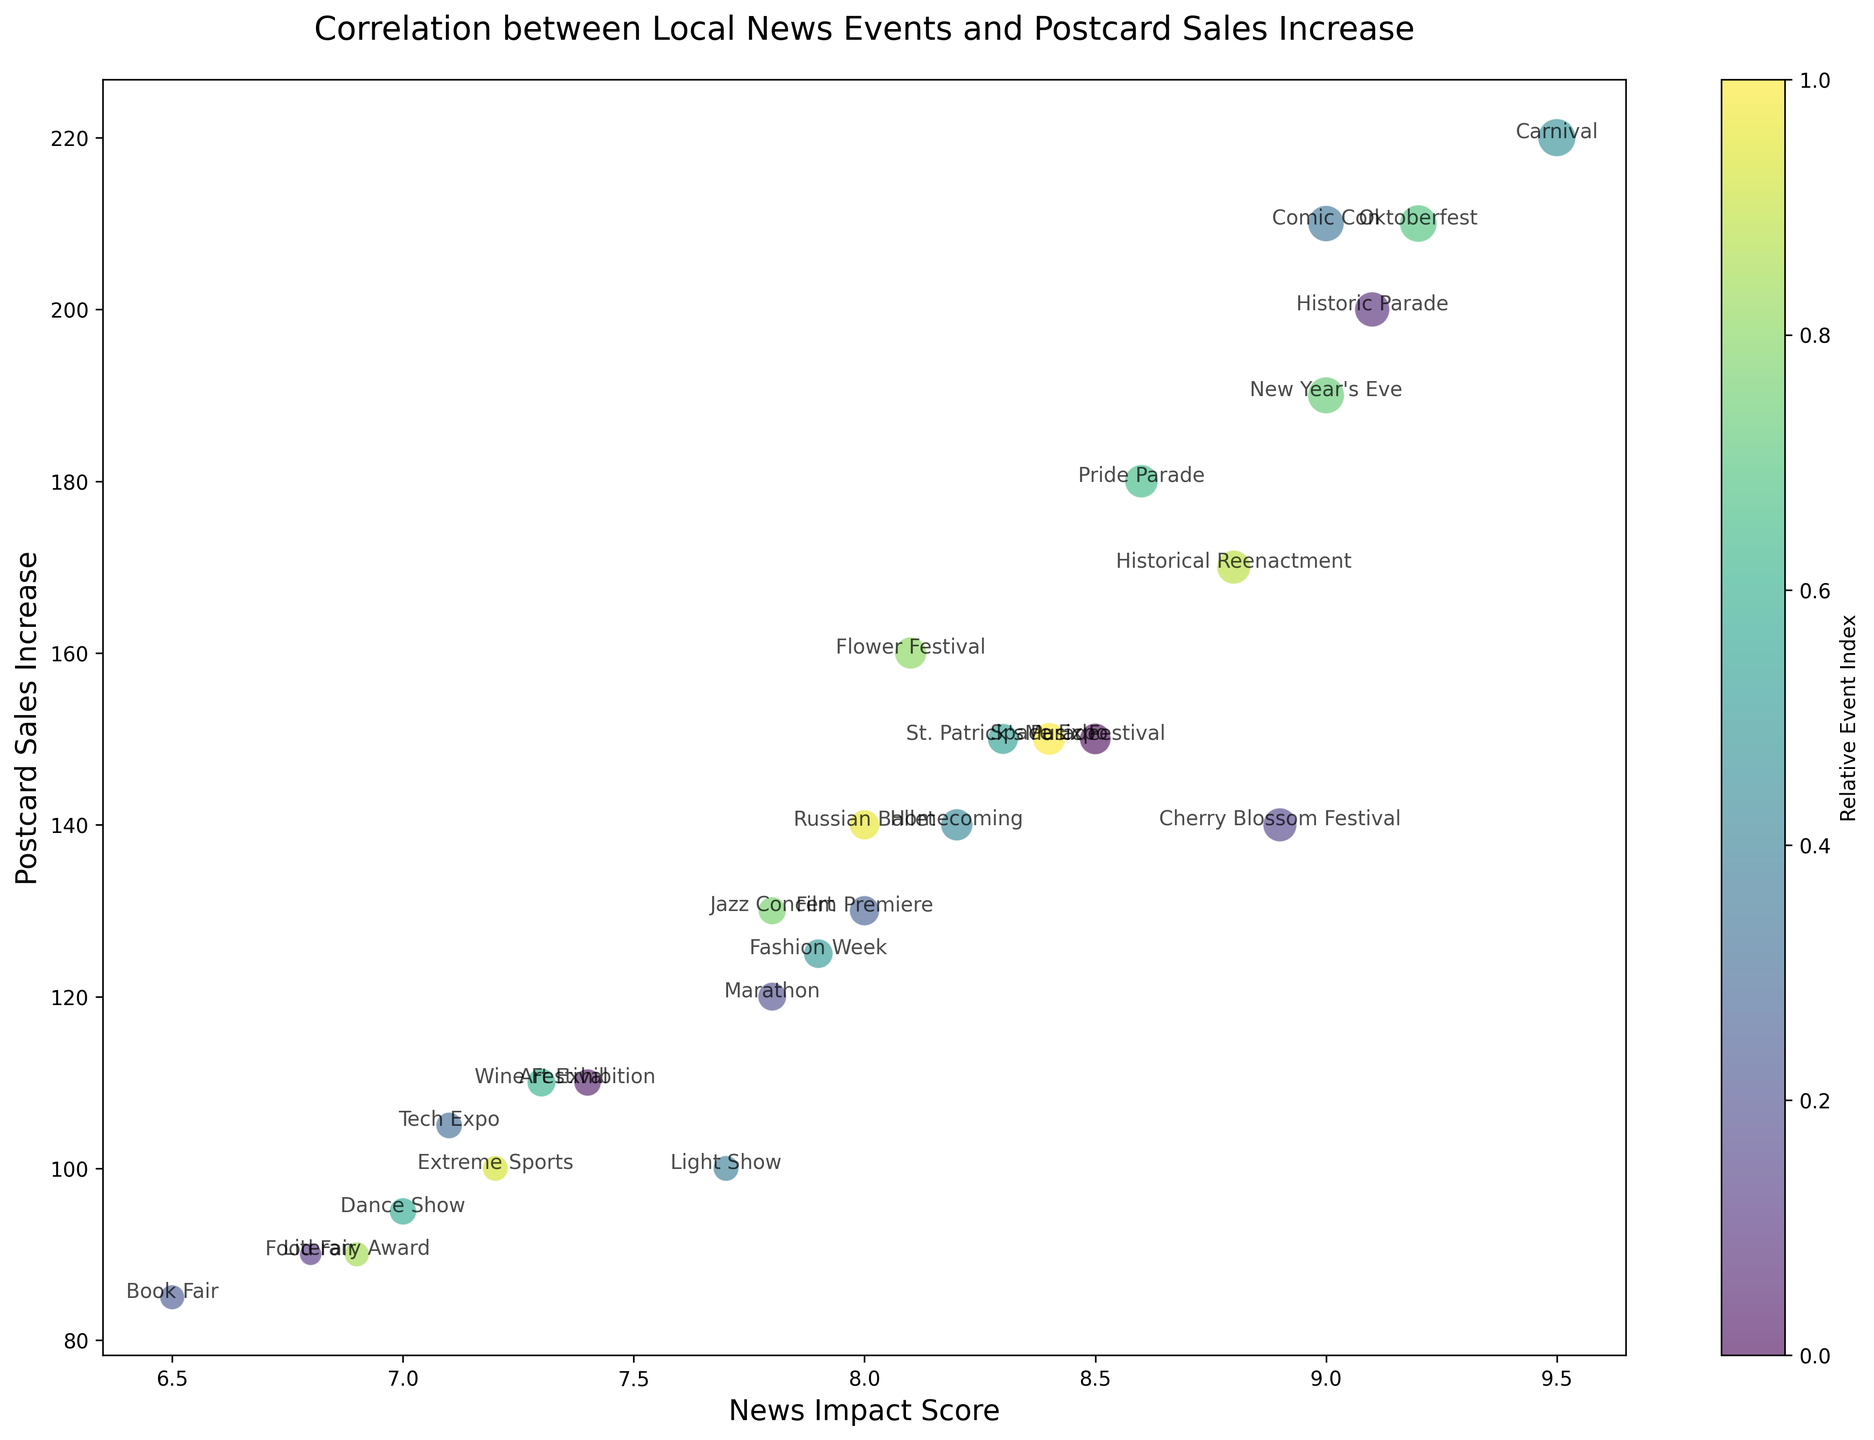What event corresponds to the highest increase in postcard sales? The event with the highest increase in postcard sales can be identified by looking for the highest point on the y-axis. The event labeled "Carnival" in Rio de Janeiro shows the highest increase at 220.
Answer: Carnival Which event had the highest News Impact Score? To find the event with the highest News Impact Score, one should look for the point furthest to the right on the x-axis. The event labeled "Carnival" corresponds to the highest News Impact Score of 9.5.
Answer: Carnival What is the general trend between News Impact Score and Postcard Sales Increase? Observing the overall distribution and direction of the bubbles, there appears to be a positive correlation between the News Impact Score (x-axis) and Postcard Sales Increase (y-axis). Higher News Impact Scores tend to be associated with higher increases in postcard sales.
Answer: Positive correlation Which event with a News Impact Score of at least 8.0 but less than 9.0 had the highest postcard sales increase? Within the News Impact Score range of 8.0 to 8.9, looking at the y-axis for the highest value, the event "Pride Parade" in San Francisco has a postcard sales increase of 180.
Answer: Pride Parade How does the popularity index affect the marker size in the plot? Bubbles with a higher Postcard Popularity Index are shown with larger marker sizes. For instance, the Carnival event, which has a high index, is represented by a larger bubble.
Answer: Larger index, larger marker Which event has a lower Postcard Sales Increase, the Jazz Concert or the Dance Show? By locating the "Jazz Concert" and "Dance Show" on the chart, it is visible that the "Jazz Concert" has a Postcard Sales Increase of 130 while the "Dance Show" has 95.
Answer: Dance Show Which locality has the most frequent event occurrences based on the plot? By examining the event labels, it is noticed that "SF" (San Francisco) appears multiple times with events like "Art Exhibition," "Pride Parade," and "Tech Expo."
Answer: SF Which event had a Postcard Popularity Index of 30? The bubble labeled with "Historic Parade" in Boston has a Postcard Popularity Index of 30, as indicated by the marker size.
Answer: Historic Parade Between the Marathon and Book Fair, which had a higher News Impact Score? By comparing the position of "Marathon" and "Book Fair" on the x-axis, the "Marathon" in Boston has a higher News Impact Score of 7.8 compared to the "Book Fair" in Seattle at 6.5.
Answer: Marathon Which event had a lower News Impact Score, the Light Show or the Fashion Week? Comparing the positions of "Light Show" and "Fashion Week" along the x-axis, "Light Show" in NYC has a News Impact Score of 7.7, while "Fashion Week" in NY has a slightly higher score of 7.9.
Answer: Light Show 